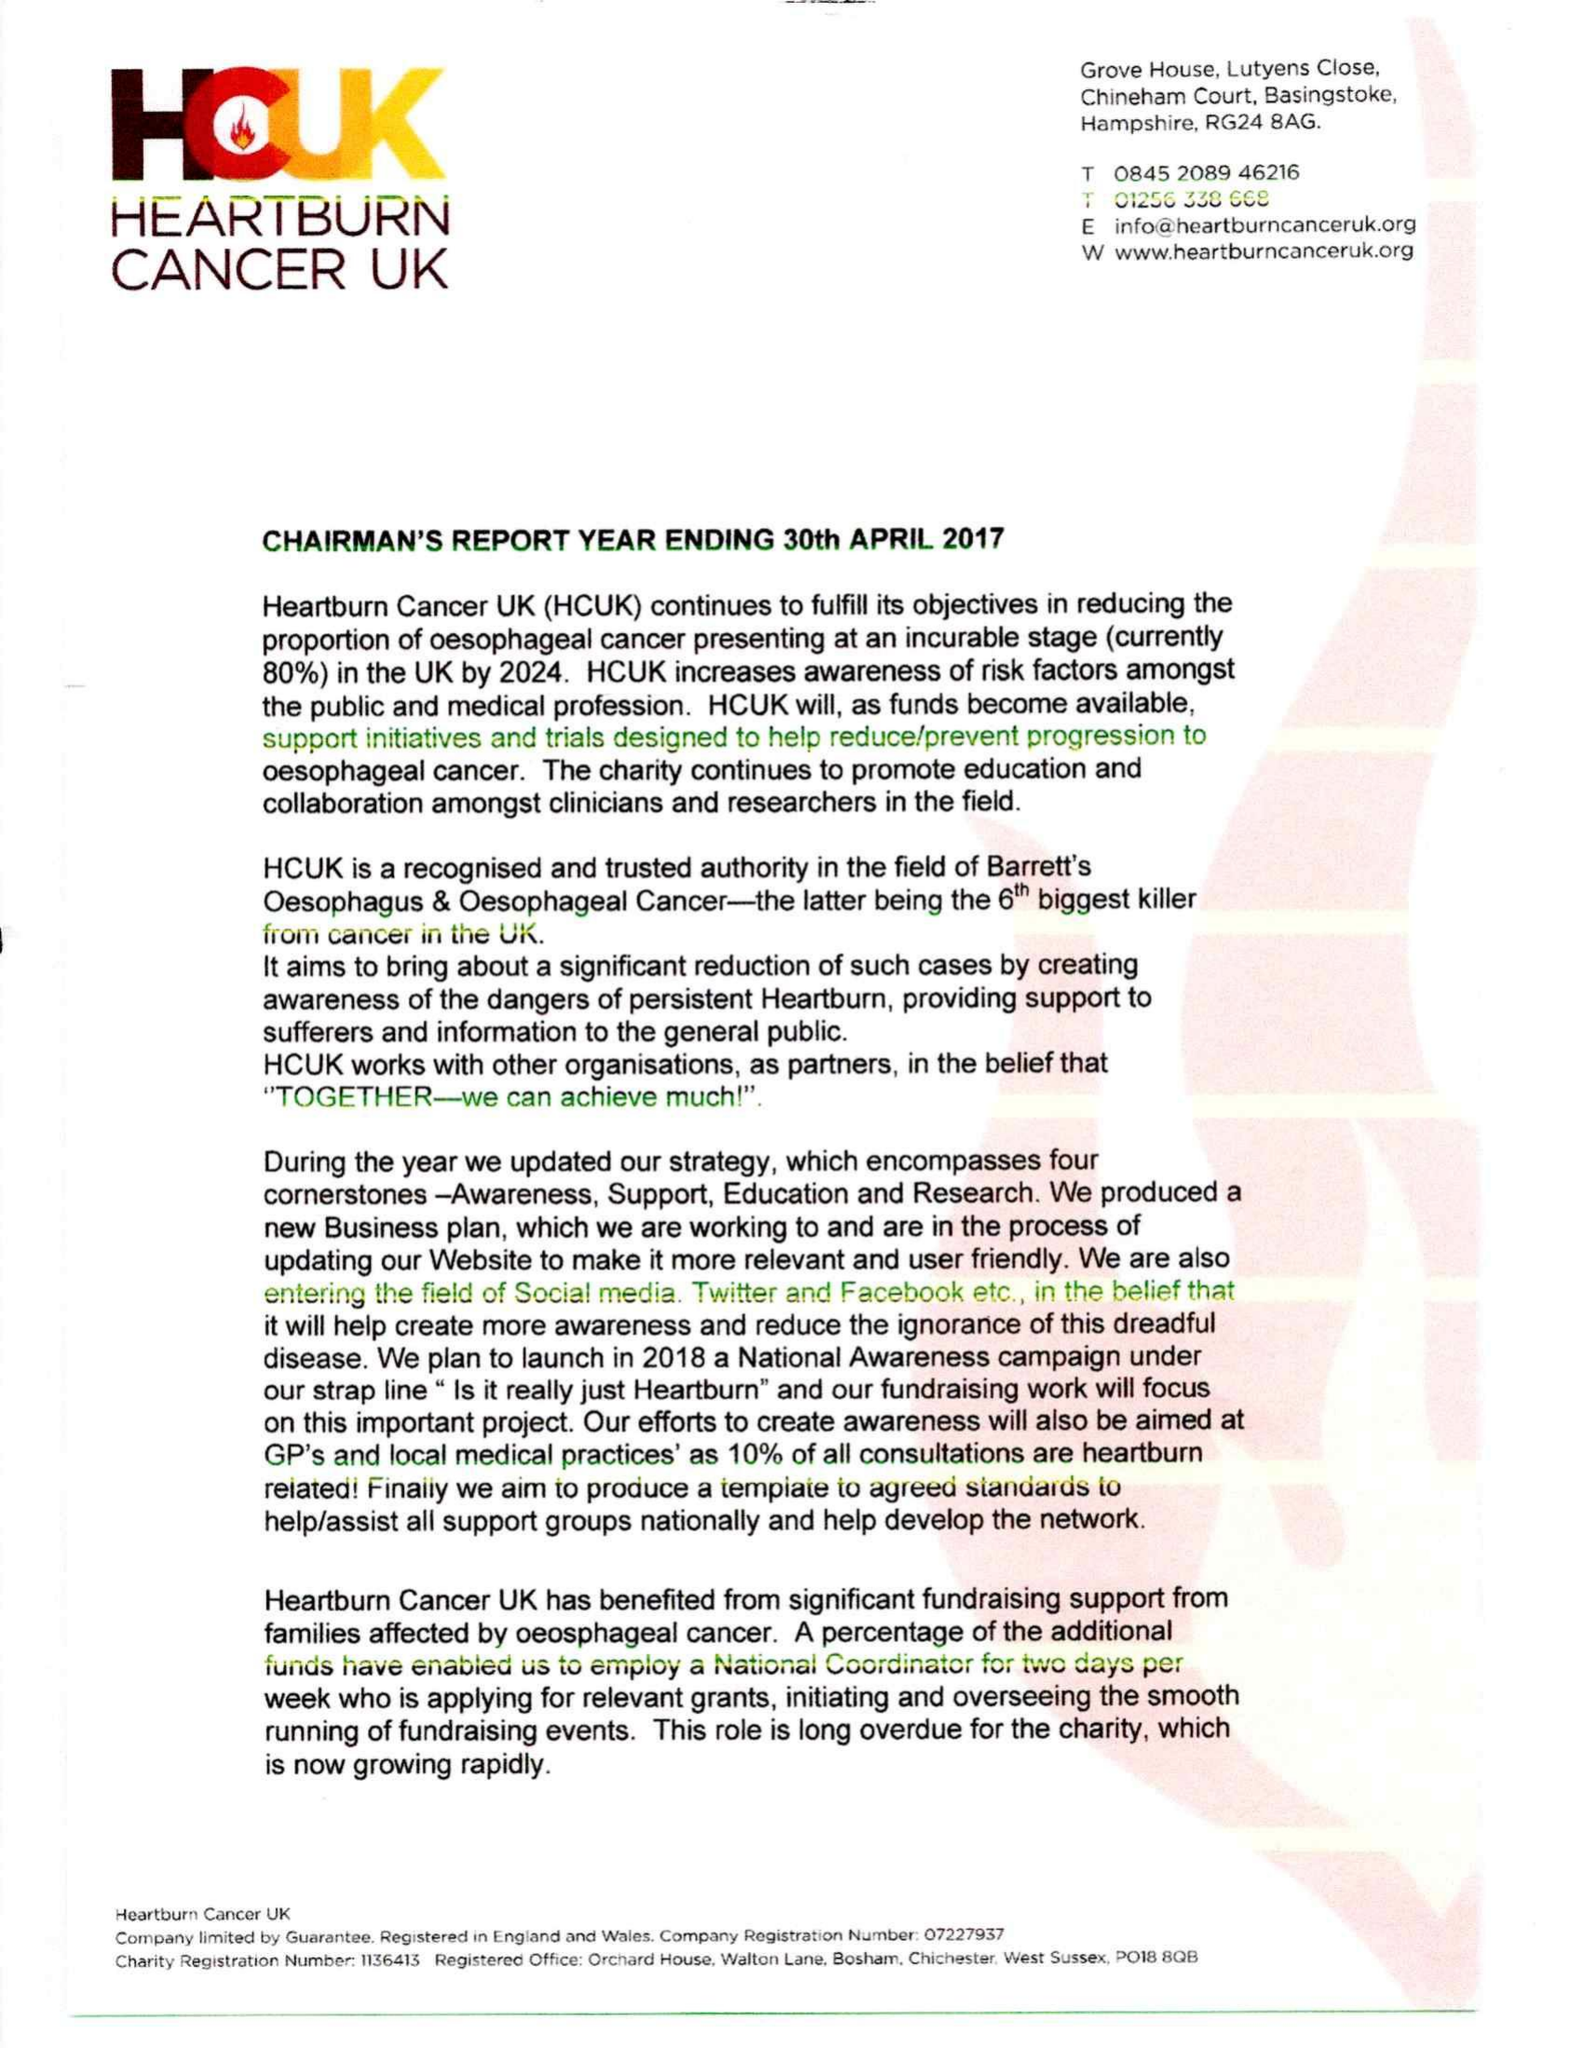What is the value for the address__postcode?
Answer the question using a single word or phrase. PO18 8QB 